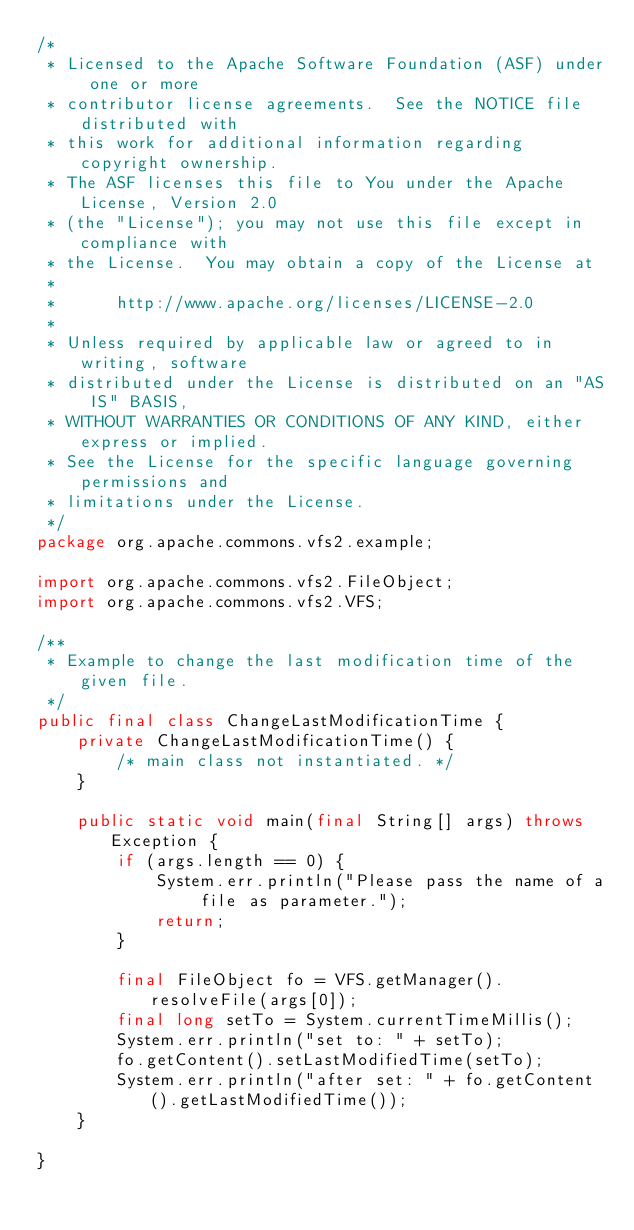Convert code to text. <code><loc_0><loc_0><loc_500><loc_500><_Java_>/*
 * Licensed to the Apache Software Foundation (ASF) under one or more
 * contributor license agreements.  See the NOTICE file distributed with
 * this work for additional information regarding copyright ownership.
 * The ASF licenses this file to You under the Apache License, Version 2.0
 * (the "License"); you may not use this file except in compliance with
 * the License.  You may obtain a copy of the License at
 *
 *      http://www.apache.org/licenses/LICENSE-2.0
 *
 * Unless required by applicable law or agreed to in writing, software
 * distributed under the License is distributed on an "AS IS" BASIS,
 * WITHOUT WARRANTIES OR CONDITIONS OF ANY KIND, either express or implied.
 * See the License for the specific language governing permissions and
 * limitations under the License.
 */
package org.apache.commons.vfs2.example;

import org.apache.commons.vfs2.FileObject;
import org.apache.commons.vfs2.VFS;

/**
 * Example to change the last modification time of the given file.
 */
public final class ChangeLastModificationTime {
    private ChangeLastModificationTime() {
        /* main class not instantiated. */
    }

    public static void main(final String[] args) throws Exception {
        if (args.length == 0) {
            System.err.println("Please pass the name of a file as parameter.");
            return;
        }

        final FileObject fo = VFS.getManager().resolveFile(args[0]);
        final long setTo = System.currentTimeMillis();
        System.err.println("set to: " + setTo);
        fo.getContent().setLastModifiedTime(setTo);
        System.err.println("after set: " + fo.getContent().getLastModifiedTime());
    }

}
</code> 